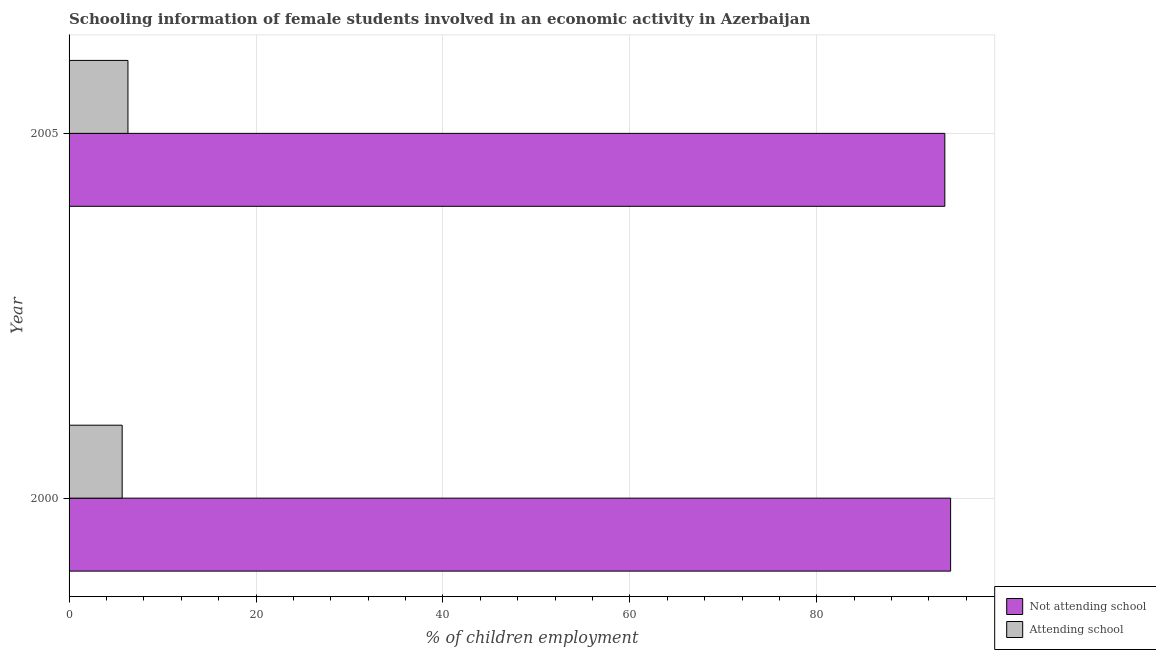How many bars are there on the 2nd tick from the top?
Give a very brief answer. 2. How many bars are there on the 2nd tick from the bottom?
Ensure brevity in your answer.  2. What is the percentage of employed females who are not attending school in 2005?
Your answer should be compact. 93.7. Across all years, what is the minimum percentage of employed females who are not attending school?
Your answer should be compact. 93.7. In which year was the percentage of employed females who are attending school minimum?
Offer a terse response. 2000. What is the total percentage of employed females who are attending school in the graph?
Your answer should be compact. 11.98. What is the difference between the percentage of employed females who are attending school in 2000 and that in 2005?
Offer a terse response. -0.62. What is the difference between the percentage of employed females who are attending school in 2000 and the percentage of employed females who are not attending school in 2005?
Your response must be concise. -88.02. What is the average percentage of employed females who are attending school per year?
Give a very brief answer. 5.99. In the year 2000, what is the difference between the percentage of employed females who are attending school and percentage of employed females who are not attending school?
Your answer should be compact. -88.64. What is the ratio of the percentage of employed females who are attending school in 2000 to that in 2005?
Make the answer very short. 0.9. Is the difference between the percentage of employed females who are not attending school in 2000 and 2005 greater than the difference between the percentage of employed females who are attending school in 2000 and 2005?
Provide a succinct answer. Yes. In how many years, is the percentage of employed females who are not attending school greater than the average percentage of employed females who are not attending school taken over all years?
Provide a succinct answer. 1. What does the 1st bar from the top in 2000 represents?
Offer a very short reply. Attending school. What does the 1st bar from the bottom in 2005 represents?
Offer a terse response. Not attending school. What is the difference between two consecutive major ticks on the X-axis?
Offer a terse response. 20. How are the legend labels stacked?
Provide a short and direct response. Vertical. What is the title of the graph?
Your answer should be very brief. Schooling information of female students involved in an economic activity in Azerbaijan. What is the label or title of the X-axis?
Keep it short and to the point. % of children employment. What is the % of children employment of Not attending school in 2000?
Your response must be concise. 94.32. What is the % of children employment in Attending school in 2000?
Offer a terse response. 5.68. What is the % of children employment in Not attending school in 2005?
Give a very brief answer. 93.7. Across all years, what is the maximum % of children employment of Not attending school?
Offer a terse response. 94.32. Across all years, what is the minimum % of children employment of Not attending school?
Ensure brevity in your answer.  93.7. Across all years, what is the minimum % of children employment of Attending school?
Your answer should be compact. 5.68. What is the total % of children employment of Not attending school in the graph?
Your answer should be very brief. 188.02. What is the total % of children employment of Attending school in the graph?
Ensure brevity in your answer.  11.98. What is the difference between the % of children employment of Not attending school in 2000 and that in 2005?
Your answer should be very brief. 0.62. What is the difference between the % of children employment of Attending school in 2000 and that in 2005?
Make the answer very short. -0.62. What is the difference between the % of children employment of Not attending school in 2000 and the % of children employment of Attending school in 2005?
Provide a short and direct response. 88.02. What is the average % of children employment in Not attending school per year?
Provide a short and direct response. 94.01. What is the average % of children employment in Attending school per year?
Make the answer very short. 5.99. In the year 2000, what is the difference between the % of children employment of Not attending school and % of children employment of Attending school?
Give a very brief answer. 88.64. In the year 2005, what is the difference between the % of children employment in Not attending school and % of children employment in Attending school?
Your answer should be very brief. 87.4. What is the ratio of the % of children employment of Not attending school in 2000 to that in 2005?
Your answer should be compact. 1.01. What is the ratio of the % of children employment in Attending school in 2000 to that in 2005?
Your answer should be very brief. 0.9. What is the difference between the highest and the second highest % of children employment in Not attending school?
Make the answer very short. 0.62. What is the difference between the highest and the second highest % of children employment in Attending school?
Offer a very short reply. 0.62. What is the difference between the highest and the lowest % of children employment of Not attending school?
Offer a very short reply. 0.62. What is the difference between the highest and the lowest % of children employment of Attending school?
Make the answer very short. 0.62. 